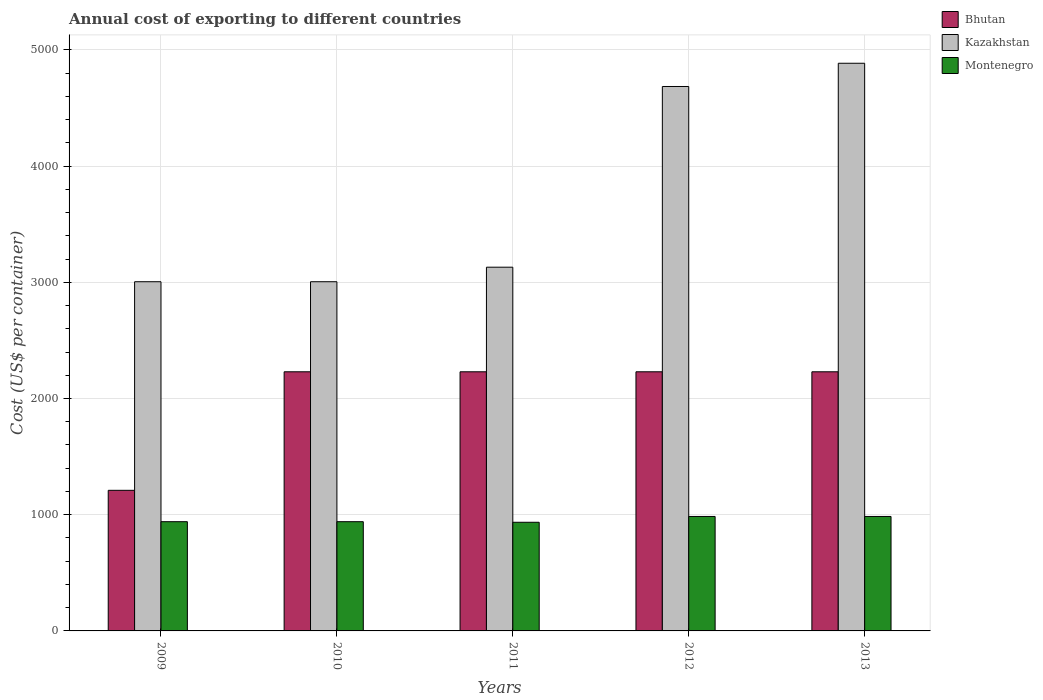Are the number of bars on each tick of the X-axis equal?
Give a very brief answer. Yes. How many bars are there on the 5th tick from the left?
Offer a very short reply. 3. How many bars are there on the 1st tick from the right?
Provide a short and direct response. 3. What is the label of the 3rd group of bars from the left?
Give a very brief answer. 2011. What is the total annual cost of exporting in Montenegro in 2012?
Offer a very short reply. 985. Across all years, what is the maximum total annual cost of exporting in Montenegro?
Your answer should be compact. 985. Across all years, what is the minimum total annual cost of exporting in Bhutan?
Your response must be concise. 1210. In which year was the total annual cost of exporting in Montenegro maximum?
Offer a very short reply. 2012. In which year was the total annual cost of exporting in Bhutan minimum?
Your answer should be very brief. 2009. What is the total total annual cost of exporting in Kazakhstan in the graph?
Keep it short and to the point. 1.87e+04. What is the difference between the total annual cost of exporting in Bhutan in 2010 and that in 2013?
Provide a succinct answer. 0. What is the difference between the total annual cost of exporting in Montenegro in 2009 and the total annual cost of exporting in Bhutan in 2013?
Provide a succinct answer. -1290. What is the average total annual cost of exporting in Montenegro per year?
Your response must be concise. 957. In the year 2013, what is the difference between the total annual cost of exporting in Bhutan and total annual cost of exporting in Kazakhstan?
Give a very brief answer. -2655. In how many years, is the total annual cost of exporting in Montenegro greater than 3400 US$?
Your answer should be compact. 0. What is the ratio of the total annual cost of exporting in Kazakhstan in 2010 to that in 2012?
Provide a short and direct response. 0.64. Is the total annual cost of exporting in Bhutan in 2012 less than that in 2013?
Offer a very short reply. No. What does the 2nd bar from the left in 2011 represents?
Keep it short and to the point. Kazakhstan. What does the 3rd bar from the right in 2012 represents?
Make the answer very short. Bhutan. Is it the case that in every year, the sum of the total annual cost of exporting in Kazakhstan and total annual cost of exporting in Montenegro is greater than the total annual cost of exporting in Bhutan?
Provide a short and direct response. Yes. Are all the bars in the graph horizontal?
Offer a terse response. No. Are the values on the major ticks of Y-axis written in scientific E-notation?
Your answer should be very brief. No. Does the graph contain any zero values?
Your answer should be very brief. No. What is the title of the graph?
Keep it short and to the point. Annual cost of exporting to different countries. Does "Tajikistan" appear as one of the legend labels in the graph?
Offer a terse response. No. What is the label or title of the Y-axis?
Your response must be concise. Cost (US$ per container). What is the Cost (US$ per container) of Bhutan in 2009?
Give a very brief answer. 1210. What is the Cost (US$ per container) of Kazakhstan in 2009?
Offer a terse response. 3005. What is the Cost (US$ per container) in Montenegro in 2009?
Your answer should be very brief. 940. What is the Cost (US$ per container) in Bhutan in 2010?
Offer a very short reply. 2230. What is the Cost (US$ per container) of Kazakhstan in 2010?
Your answer should be compact. 3005. What is the Cost (US$ per container) of Montenegro in 2010?
Provide a short and direct response. 940. What is the Cost (US$ per container) of Bhutan in 2011?
Offer a terse response. 2230. What is the Cost (US$ per container) of Kazakhstan in 2011?
Your answer should be very brief. 3130. What is the Cost (US$ per container) of Montenegro in 2011?
Offer a very short reply. 935. What is the Cost (US$ per container) of Bhutan in 2012?
Your answer should be compact. 2230. What is the Cost (US$ per container) in Kazakhstan in 2012?
Offer a very short reply. 4685. What is the Cost (US$ per container) of Montenegro in 2012?
Offer a very short reply. 985. What is the Cost (US$ per container) of Bhutan in 2013?
Give a very brief answer. 2230. What is the Cost (US$ per container) of Kazakhstan in 2013?
Provide a short and direct response. 4885. What is the Cost (US$ per container) in Montenegro in 2013?
Keep it short and to the point. 985. Across all years, what is the maximum Cost (US$ per container) of Bhutan?
Your response must be concise. 2230. Across all years, what is the maximum Cost (US$ per container) in Kazakhstan?
Ensure brevity in your answer.  4885. Across all years, what is the maximum Cost (US$ per container) of Montenegro?
Keep it short and to the point. 985. Across all years, what is the minimum Cost (US$ per container) in Bhutan?
Provide a short and direct response. 1210. Across all years, what is the minimum Cost (US$ per container) of Kazakhstan?
Make the answer very short. 3005. Across all years, what is the minimum Cost (US$ per container) of Montenegro?
Provide a short and direct response. 935. What is the total Cost (US$ per container) of Bhutan in the graph?
Your answer should be very brief. 1.01e+04. What is the total Cost (US$ per container) of Kazakhstan in the graph?
Make the answer very short. 1.87e+04. What is the total Cost (US$ per container) of Montenegro in the graph?
Offer a terse response. 4785. What is the difference between the Cost (US$ per container) in Bhutan in 2009 and that in 2010?
Your answer should be very brief. -1020. What is the difference between the Cost (US$ per container) in Bhutan in 2009 and that in 2011?
Make the answer very short. -1020. What is the difference between the Cost (US$ per container) of Kazakhstan in 2009 and that in 2011?
Your response must be concise. -125. What is the difference between the Cost (US$ per container) of Bhutan in 2009 and that in 2012?
Offer a very short reply. -1020. What is the difference between the Cost (US$ per container) in Kazakhstan in 2009 and that in 2012?
Your answer should be very brief. -1680. What is the difference between the Cost (US$ per container) of Montenegro in 2009 and that in 2012?
Ensure brevity in your answer.  -45. What is the difference between the Cost (US$ per container) in Bhutan in 2009 and that in 2013?
Ensure brevity in your answer.  -1020. What is the difference between the Cost (US$ per container) in Kazakhstan in 2009 and that in 2013?
Provide a short and direct response. -1880. What is the difference between the Cost (US$ per container) of Montenegro in 2009 and that in 2013?
Ensure brevity in your answer.  -45. What is the difference between the Cost (US$ per container) in Bhutan in 2010 and that in 2011?
Provide a succinct answer. 0. What is the difference between the Cost (US$ per container) in Kazakhstan in 2010 and that in 2011?
Offer a very short reply. -125. What is the difference between the Cost (US$ per container) in Kazakhstan in 2010 and that in 2012?
Offer a very short reply. -1680. What is the difference between the Cost (US$ per container) in Montenegro in 2010 and that in 2012?
Your response must be concise. -45. What is the difference between the Cost (US$ per container) in Bhutan in 2010 and that in 2013?
Your response must be concise. 0. What is the difference between the Cost (US$ per container) of Kazakhstan in 2010 and that in 2013?
Your response must be concise. -1880. What is the difference between the Cost (US$ per container) of Montenegro in 2010 and that in 2013?
Make the answer very short. -45. What is the difference between the Cost (US$ per container) in Kazakhstan in 2011 and that in 2012?
Provide a succinct answer. -1555. What is the difference between the Cost (US$ per container) in Bhutan in 2011 and that in 2013?
Make the answer very short. 0. What is the difference between the Cost (US$ per container) of Kazakhstan in 2011 and that in 2013?
Make the answer very short. -1755. What is the difference between the Cost (US$ per container) in Montenegro in 2011 and that in 2013?
Offer a terse response. -50. What is the difference between the Cost (US$ per container) in Kazakhstan in 2012 and that in 2013?
Keep it short and to the point. -200. What is the difference between the Cost (US$ per container) of Montenegro in 2012 and that in 2013?
Provide a short and direct response. 0. What is the difference between the Cost (US$ per container) in Bhutan in 2009 and the Cost (US$ per container) in Kazakhstan in 2010?
Keep it short and to the point. -1795. What is the difference between the Cost (US$ per container) of Bhutan in 2009 and the Cost (US$ per container) of Montenegro in 2010?
Your response must be concise. 270. What is the difference between the Cost (US$ per container) of Kazakhstan in 2009 and the Cost (US$ per container) of Montenegro in 2010?
Give a very brief answer. 2065. What is the difference between the Cost (US$ per container) of Bhutan in 2009 and the Cost (US$ per container) of Kazakhstan in 2011?
Give a very brief answer. -1920. What is the difference between the Cost (US$ per container) in Bhutan in 2009 and the Cost (US$ per container) in Montenegro in 2011?
Give a very brief answer. 275. What is the difference between the Cost (US$ per container) in Kazakhstan in 2009 and the Cost (US$ per container) in Montenegro in 2011?
Provide a succinct answer. 2070. What is the difference between the Cost (US$ per container) of Bhutan in 2009 and the Cost (US$ per container) of Kazakhstan in 2012?
Provide a short and direct response. -3475. What is the difference between the Cost (US$ per container) of Bhutan in 2009 and the Cost (US$ per container) of Montenegro in 2012?
Provide a succinct answer. 225. What is the difference between the Cost (US$ per container) in Kazakhstan in 2009 and the Cost (US$ per container) in Montenegro in 2012?
Your response must be concise. 2020. What is the difference between the Cost (US$ per container) of Bhutan in 2009 and the Cost (US$ per container) of Kazakhstan in 2013?
Offer a very short reply. -3675. What is the difference between the Cost (US$ per container) in Bhutan in 2009 and the Cost (US$ per container) in Montenegro in 2013?
Ensure brevity in your answer.  225. What is the difference between the Cost (US$ per container) in Kazakhstan in 2009 and the Cost (US$ per container) in Montenegro in 2013?
Provide a succinct answer. 2020. What is the difference between the Cost (US$ per container) of Bhutan in 2010 and the Cost (US$ per container) of Kazakhstan in 2011?
Your answer should be very brief. -900. What is the difference between the Cost (US$ per container) in Bhutan in 2010 and the Cost (US$ per container) in Montenegro in 2011?
Your response must be concise. 1295. What is the difference between the Cost (US$ per container) of Kazakhstan in 2010 and the Cost (US$ per container) of Montenegro in 2011?
Keep it short and to the point. 2070. What is the difference between the Cost (US$ per container) of Bhutan in 2010 and the Cost (US$ per container) of Kazakhstan in 2012?
Make the answer very short. -2455. What is the difference between the Cost (US$ per container) in Bhutan in 2010 and the Cost (US$ per container) in Montenegro in 2012?
Offer a terse response. 1245. What is the difference between the Cost (US$ per container) in Kazakhstan in 2010 and the Cost (US$ per container) in Montenegro in 2012?
Provide a succinct answer. 2020. What is the difference between the Cost (US$ per container) of Bhutan in 2010 and the Cost (US$ per container) of Kazakhstan in 2013?
Provide a short and direct response. -2655. What is the difference between the Cost (US$ per container) of Bhutan in 2010 and the Cost (US$ per container) of Montenegro in 2013?
Your answer should be compact. 1245. What is the difference between the Cost (US$ per container) of Kazakhstan in 2010 and the Cost (US$ per container) of Montenegro in 2013?
Give a very brief answer. 2020. What is the difference between the Cost (US$ per container) in Bhutan in 2011 and the Cost (US$ per container) in Kazakhstan in 2012?
Provide a succinct answer. -2455. What is the difference between the Cost (US$ per container) of Bhutan in 2011 and the Cost (US$ per container) of Montenegro in 2012?
Provide a short and direct response. 1245. What is the difference between the Cost (US$ per container) of Kazakhstan in 2011 and the Cost (US$ per container) of Montenegro in 2012?
Offer a very short reply. 2145. What is the difference between the Cost (US$ per container) in Bhutan in 2011 and the Cost (US$ per container) in Kazakhstan in 2013?
Your response must be concise. -2655. What is the difference between the Cost (US$ per container) in Bhutan in 2011 and the Cost (US$ per container) in Montenegro in 2013?
Keep it short and to the point. 1245. What is the difference between the Cost (US$ per container) of Kazakhstan in 2011 and the Cost (US$ per container) of Montenegro in 2013?
Make the answer very short. 2145. What is the difference between the Cost (US$ per container) of Bhutan in 2012 and the Cost (US$ per container) of Kazakhstan in 2013?
Your response must be concise. -2655. What is the difference between the Cost (US$ per container) in Bhutan in 2012 and the Cost (US$ per container) in Montenegro in 2013?
Provide a succinct answer. 1245. What is the difference between the Cost (US$ per container) of Kazakhstan in 2012 and the Cost (US$ per container) of Montenegro in 2013?
Your answer should be compact. 3700. What is the average Cost (US$ per container) of Bhutan per year?
Ensure brevity in your answer.  2026. What is the average Cost (US$ per container) of Kazakhstan per year?
Ensure brevity in your answer.  3742. What is the average Cost (US$ per container) of Montenegro per year?
Offer a terse response. 957. In the year 2009, what is the difference between the Cost (US$ per container) of Bhutan and Cost (US$ per container) of Kazakhstan?
Keep it short and to the point. -1795. In the year 2009, what is the difference between the Cost (US$ per container) in Bhutan and Cost (US$ per container) in Montenegro?
Give a very brief answer. 270. In the year 2009, what is the difference between the Cost (US$ per container) in Kazakhstan and Cost (US$ per container) in Montenegro?
Provide a short and direct response. 2065. In the year 2010, what is the difference between the Cost (US$ per container) in Bhutan and Cost (US$ per container) in Kazakhstan?
Keep it short and to the point. -775. In the year 2010, what is the difference between the Cost (US$ per container) in Bhutan and Cost (US$ per container) in Montenegro?
Your answer should be compact. 1290. In the year 2010, what is the difference between the Cost (US$ per container) in Kazakhstan and Cost (US$ per container) in Montenegro?
Provide a short and direct response. 2065. In the year 2011, what is the difference between the Cost (US$ per container) in Bhutan and Cost (US$ per container) in Kazakhstan?
Offer a terse response. -900. In the year 2011, what is the difference between the Cost (US$ per container) in Bhutan and Cost (US$ per container) in Montenegro?
Give a very brief answer. 1295. In the year 2011, what is the difference between the Cost (US$ per container) in Kazakhstan and Cost (US$ per container) in Montenegro?
Keep it short and to the point. 2195. In the year 2012, what is the difference between the Cost (US$ per container) in Bhutan and Cost (US$ per container) in Kazakhstan?
Make the answer very short. -2455. In the year 2012, what is the difference between the Cost (US$ per container) of Bhutan and Cost (US$ per container) of Montenegro?
Your answer should be very brief. 1245. In the year 2012, what is the difference between the Cost (US$ per container) in Kazakhstan and Cost (US$ per container) in Montenegro?
Offer a very short reply. 3700. In the year 2013, what is the difference between the Cost (US$ per container) in Bhutan and Cost (US$ per container) in Kazakhstan?
Your answer should be compact. -2655. In the year 2013, what is the difference between the Cost (US$ per container) in Bhutan and Cost (US$ per container) in Montenegro?
Make the answer very short. 1245. In the year 2013, what is the difference between the Cost (US$ per container) in Kazakhstan and Cost (US$ per container) in Montenegro?
Make the answer very short. 3900. What is the ratio of the Cost (US$ per container) in Bhutan in 2009 to that in 2010?
Offer a very short reply. 0.54. What is the ratio of the Cost (US$ per container) of Kazakhstan in 2009 to that in 2010?
Your answer should be very brief. 1. What is the ratio of the Cost (US$ per container) of Montenegro in 2009 to that in 2010?
Ensure brevity in your answer.  1. What is the ratio of the Cost (US$ per container) in Bhutan in 2009 to that in 2011?
Offer a terse response. 0.54. What is the ratio of the Cost (US$ per container) in Kazakhstan in 2009 to that in 2011?
Offer a terse response. 0.96. What is the ratio of the Cost (US$ per container) of Montenegro in 2009 to that in 2011?
Provide a succinct answer. 1.01. What is the ratio of the Cost (US$ per container) in Bhutan in 2009 to that in 2012?
Make the answer very short. 0.54. What is the ratio of the Cost (US$ per container) in Kazakhstan in 2009 to that in 2012?
Your answer should be compact. 0.64. What is the ratio of the Cost (US$ per container) of Montenegro in 2009 to that in 2012?
Provide a short and direct response. 0.95. What is the ratio of the Cost (US$ per container) in Bhutan in 2009 to that in 2013?
Ensure brevity in your answer.  0.54. What is the ratio of the Cost (US$ per container) in Kazakhstan in 2009 to that in 2013?
Provide a succinct answer. 0.62. What is the ratio of the Cost (US$ per container) of Montenegro in 2009 to that in 2013?
Your answer should be compact. 0.95. What is the ratio of the Cost (US$ per container) in Bhutan in 2010 to that in 2011?
Your answer should be very brief. 1. What is the ratio of the Cost (US$ per container) in Kazakhstan in 2010 to that in 2011?
Your answer should be compact. 0.96. What is the ratio of the Cost (US$ per container) in Montenegro in 2010 to that in 2011?
Ensure brevity in your answer.  1.01. What is the ratio of the Cost (US$ per container) of Kazakhstan in 2010 to that in 2012?
Keep it short and to the point. 0.64. What is the ratio of the Cost (US$ per container) of Montenegro in 2010 to that in 2012?
Offer a terse response. 0.95. What is the ratio of the Cost (US$ per container) in Kazakhstan in 2010 to that in 2013?
Offer a very short reply. 0.62. What is the ratio of the Cost (US$ per container) of Montenegro in 2010 to that in 2013?
Offer a terse response. 0.95. What is the ratio of the Cost (US$ per container) in Kazakhstan in 2011 to that in 2012?
Ensure brevity in your answer.  0.67. What is the ratio of the Cost (US$ per container) of Montenegro in 2011 to that in 2012?
Ensure brevity in your answer.  0.95. What is the ratio of the Cost (US$ per container) in Bhutan in 2011 to that in 2013?
Keep it short and to the point. 1. What is the ratio of the Cost (US$ per container) in Kazakhstan in 2011 to that in 2013?
Ensure brevity in your answer.  0.64. What is the ratio of the Cost (US$ per container) in Montenegro in 2011 to that in 2013?
Keep it short and to the point. 0.95. What is the ratio of the Cost (US$ per container) in Kazakhstan in 2012 to that in 2013?
Provide a succinct answer. 0.96. What is the ratio of the Cost (US$ per container) in Montenegro in 2012 to that in 2013?
Give a very brief answer. 1. What is the difference between the highest and the second highest Cost (US$ per container) of Bhutan?
Keep it short and to the point. 0. What is the difference between the highest and the second highest Cost (US$ per container) in Montenegro?
Offer a terse response. 0. What is the difference between the highest and the lowest Cost (US$ per container) in Bhutan?
Your response must be concise. 1020. What is the difference between the highest and the lowest Cost (US$ per container) of Kazakhstan?
Keep it short and to the point. 1880. What is the difference between the highest and the lowest Cost (US$ per container) in Montenegro?
Your answer should be very brief. 50. 